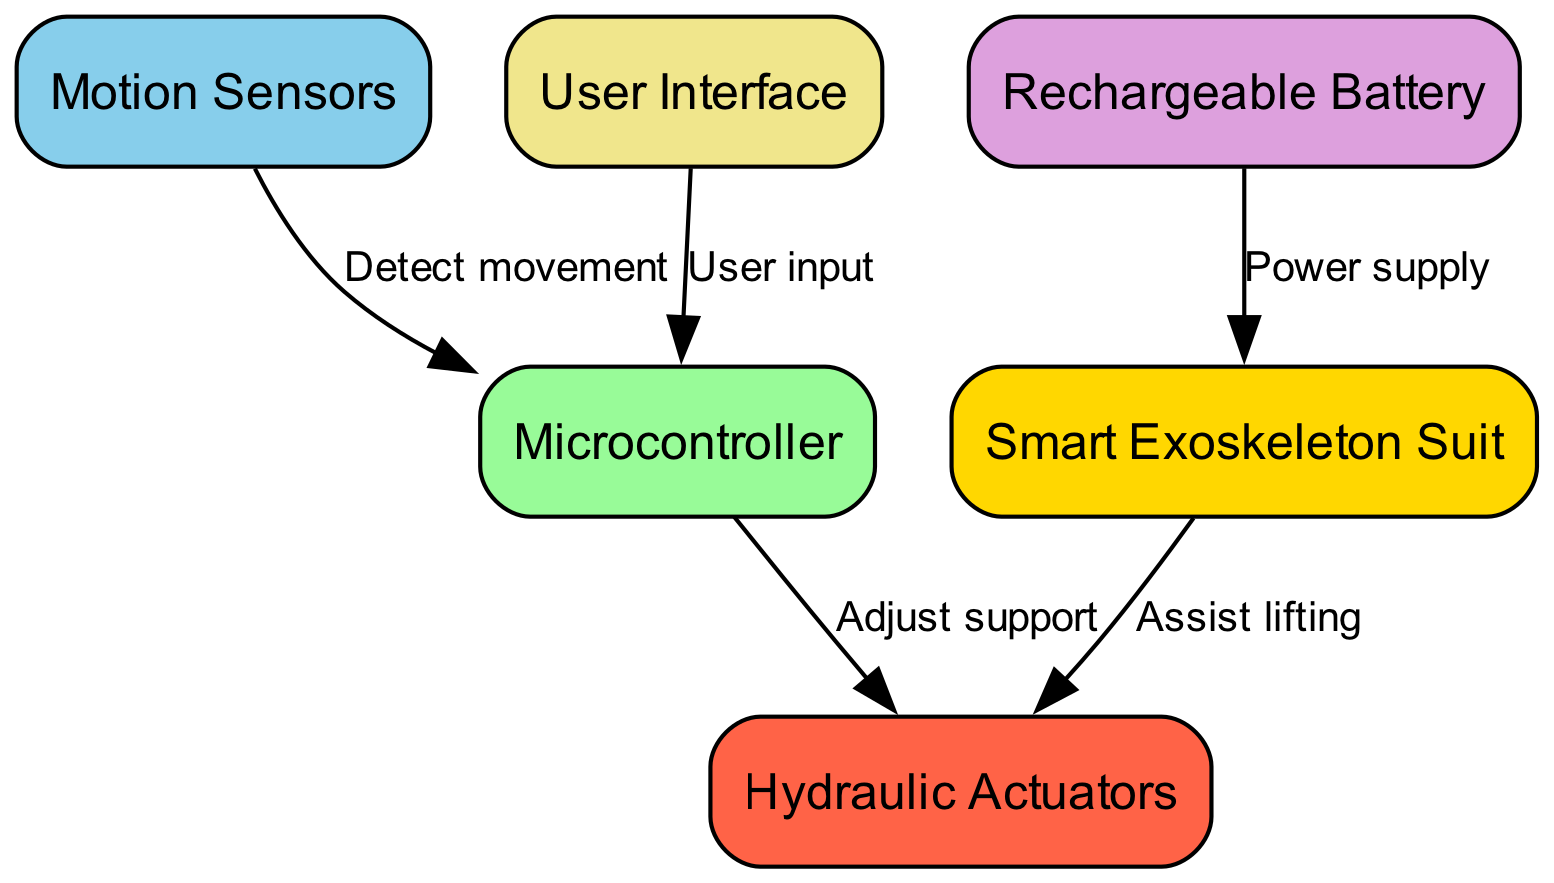What is the main component that assists in lifting? The "Smart Exoskeleton Suit" node is linked to the "Hydraulic Actuators" node with a direct edge labeled "Assist lifting," indicating that the suit directly provides assistance for lifting.
Answer: Hydraulic Actuators How many nodes are in this diagram? The nodes listed are: Smart Exoskeleton Suit, Motion Sensors, Hydraulic Actuators, Microcontroller, Rechargeable Battery, and User Interface, totaling 6 nodes when counted.
Answer: 6 Which component detects movement? The "Motion Sensors" node is designated to detect movement and is connected to the "Microcontroller" with the edge labeled "Detect movement."
Answer: Motion Sensors What supplies power to the exosuit? The "Rechargeable Battery" node is linked to the "Smart Exoskeleton Suit" node with the edge labeled "Power supply," indicating that it is the source of power for the suit.
Answer: Rechargeable Battery What is the relationship between the Microcontroller and the Hydraulic Actuators? The edge labeled "Adjust support" connects the "Microcontroller" to the "Hydraulic Actuators," indicating that the control unit adjusts the support provided by the actuators.
Answer: Adjust support How does the user interact with the control system? The "User Interface" node connects to the "Microcontroller" with the edge labeled "User input," showing that the user inputs commands into the control system through this interface.
Answer: User input What color represents the Smart Exoskeleton Suit in the diagram? Looking at the color scheme provided for the nodes, the color assigned to the "Smart Exoskeleton Suit" is gold (hex code #FFD700).
Answer: Gold What role do the Hydraulic Actuators play in the exosuit's functionality? The "Hydraulic Actuators" are shown to assist directly with lifting as indicated by the label on the edge connecting them to the "Smart Exoskeleton Suit," demonstrating their function.
Answer: Assist lifting Which component does the Microcontroller receive input from? The "Microcontroller" receives input from the "User Interface" as indicated by the edge labeled "User input," making this connection clear in the diagram.
Answer: User Interface What is the purpose of the Motion Sensors in the exosuit? The "Motion Sensors" are crucial for detecting movement, which is shown by their connection to the "Microcontroller" indicating they alert the control system about the user's movements.
Answer: Detect movement 